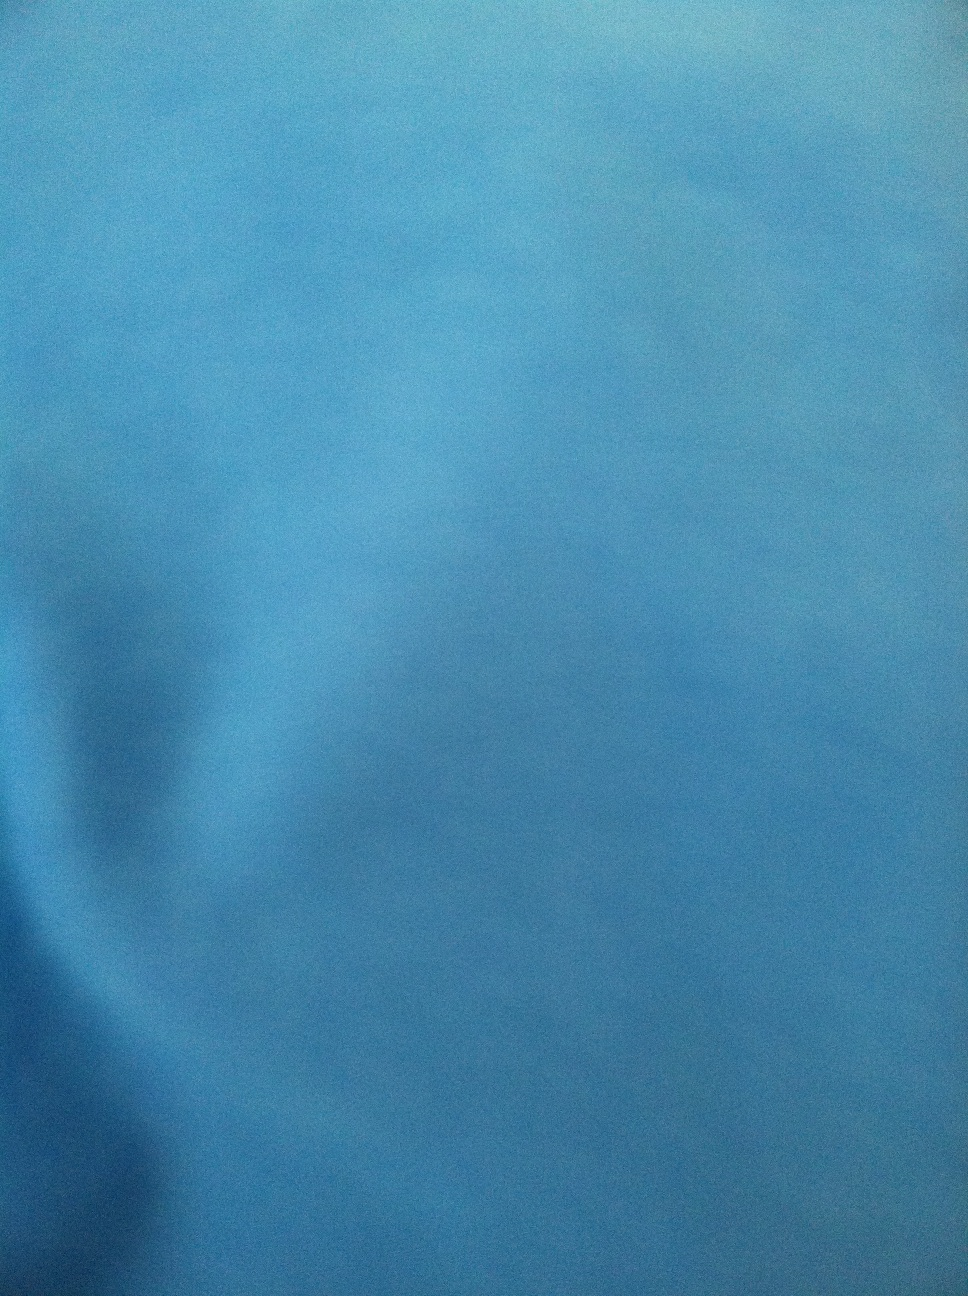What occasions would this color and style of dress be suitable for? The blue color of the dress is versatile and can be suitable for a wide range of occasions, from casual gatherings to more formal events. The subtle elegance of the color makes it a good choice for both daytime and evening events. 